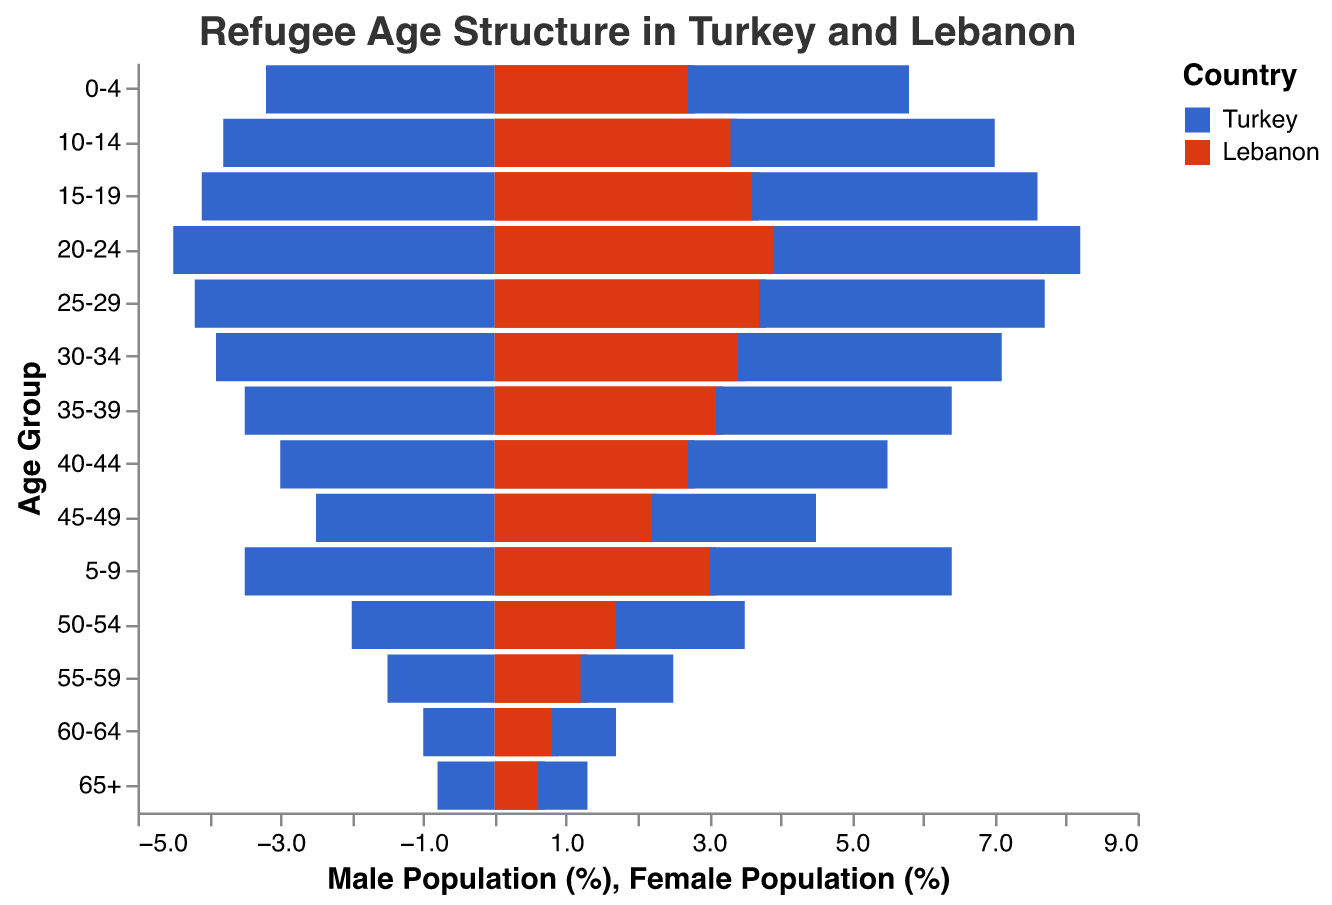What's the title of the figure? The title of the figure is usually found at the top and is meant to provide a brief description of the data being presented. By looking at the top of the figure, we can see the title.
Answer: Refugee Age Structure in Turkey and Lebanon What age group has the highest male refugee population in Turkey? By examining the bars representing the male population for Turkey, the longest bar indicates the highest population. The age group 20-24 for males has the highest value in Turkey.
Answer: 20-24 How does the female refugee population in Lebanon for the age group 25-29 compare to the male population in the same age group? We compare the length of the bars for the male and female populations in Lebanon for the 25-29 age group. The lengths show that the female population is slightly less than the male population.
Answer: Slightly less What is the approximate difference in the male refugee population percentages between the age group 15-19 in Turkey and Lebanon? First, we identify the values for the male population in the 15-19 age group in both countries: Turkey (4.1) and Lebanon (3.7). Subtract the smaller value from the larger one: 4.1 - 3.7.
Answer: 0.4 Which age group has the lowest refugee population in Lebanon for both males and females? By observing the lengths of the bars for male and female populations in Lebanon, the shortest bars indicate the lowest population. The age group 65+ for both males and females in Lebanon has the lowest population.
Answer: 65+ Compare the male refugee population percentages for the age group 0-4 in Turkey and Lebanon. Which country has a higher percentage? We look at the bars for the male population in the 0-4 age group and compare their lengths. For Turkey, it is 3.2, and for Lebanon, it is 2.8. Thus, Turkey has a higher percentage.
Answer: Turkey What is the combined percentage of male and female refugees in the 60-64 age group in Turkey? We sum the male and female percentages in the 60-64 age group for Turkey: 1.0 (male) + 0.9 (female).
Answer: 1.9 In which country is the refugee population more evenly distributed across different age groups? By examining the uniformity of the lengths of the bars across different age groups for both countries, Lebanon shows a more even distribution compared to Turkey, where there are more noticeable variations in bar lengths.
Answer: Lebanon Between the countries, which has a higher percentage of female refugees in the 55-59 age group? We compare the bars for the female population in the 55-59 age group in both countries. Lebanon's bar has a value of 1.2, while Turkey's has a value of 1.3, showing that Turkey has a higher percentage.
Answer: Turkey What is the percentage difference between male and female refugees in the 20-24 age group in Turkey? We take the values for males (4.5) and females (4.3) in the 20-24 age group in Turkey and subtract the smaller value from the larger one: 4.5 - 4.3.
Answer: 0.2 